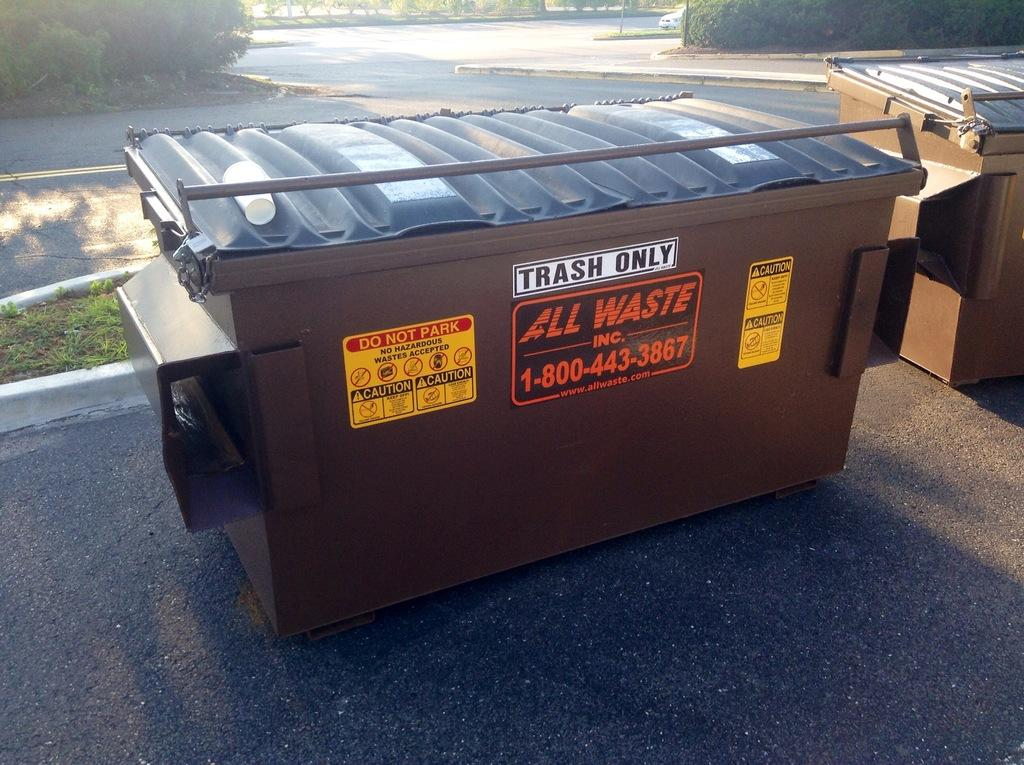<image>
Create a compact narrative representing the image presented. Black garbage can with a white sign that says TRASH ONLY. 